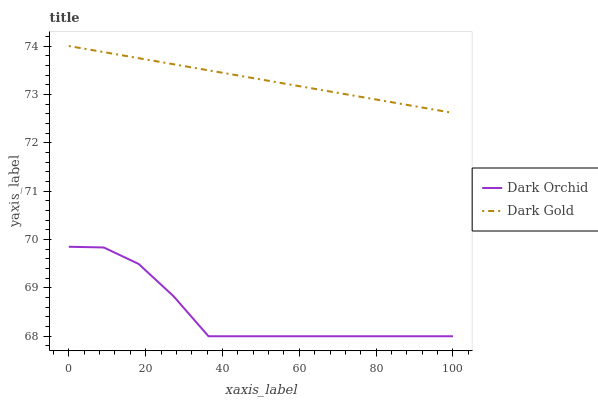Does Dark Orchid have the minimum area under the curve?
Answer yes or no. Yes. Does Dark Gold have the maximum area under the curve?
Answer yes or no. Yes. Does Dark Gold have the minimum area under the curve?
Answer yes or no. No. Is Dark Gold the smoothest?
Answer yes or no. Yes. Is Dark Orchid the roughest?
Answer yes or no. Yes. Is Dark Gold the roughest?
Answer yes or no. No. Does Dark Orchid have the lowest value?
Answer yes or no. Yes. Does Dark Gold have the lowest value?
Answer yes or no. No. Does Dark Gold have the highest value?
Answer yes or no. Yes. Is Dark Orchid less than Dark Gold?
Answer yes or no. Yes. Is Dark Gold greater than Dark Orchid?
Answer yes or no. Yes. Does Dark Orchid intersect Dark Gold?
Answer yes or no. No. 